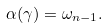Convert formula to latex. <formula><loc_0><loc_0><loc_500><loc_500>\alpha ( \gamma ) = \omega _ { n - 1 } .</formula> 